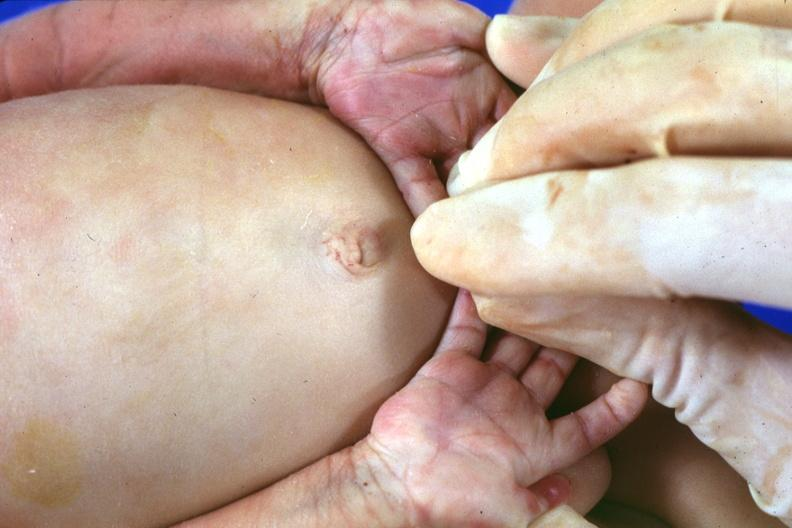what does this image show?
Answer the question using a single word or phrase. Simian crease 